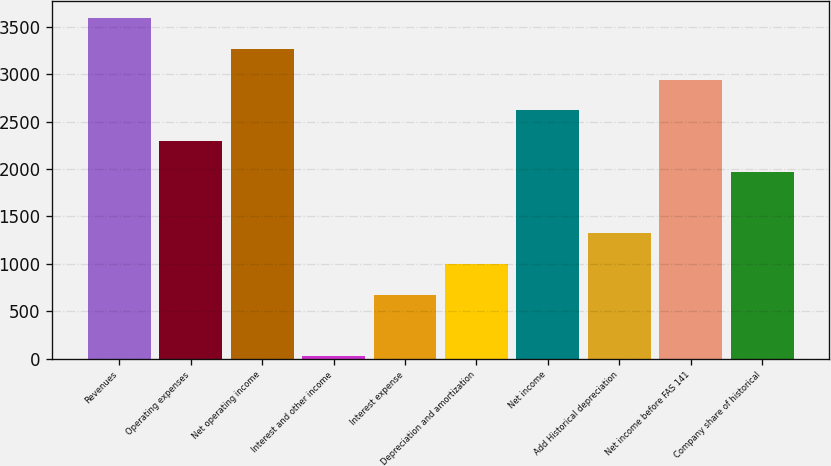Convert chart to OTSL. <chart><loc_0><loc_0><loc_500><loc_500><bar_chart><fcel>Revenues<fcel>Operating expenses<fcel>Net operating income<fcel>Interest and other income<fcel>Interest expense<fcel>Depreciation and amortization<fcel>Net income<fcel>Add Historical depreciation<fcel>Net income before FAS 141<fcel>Company share of historical<nl><fcel>3595.4<fcel>2297.8<fcel>3271<fcel>27<fcel>675.8<fcel>1000.2<fcel>2622.2<fcel>1324.6<fcel>2946.6<fcel>1973.4<nl></chart> 